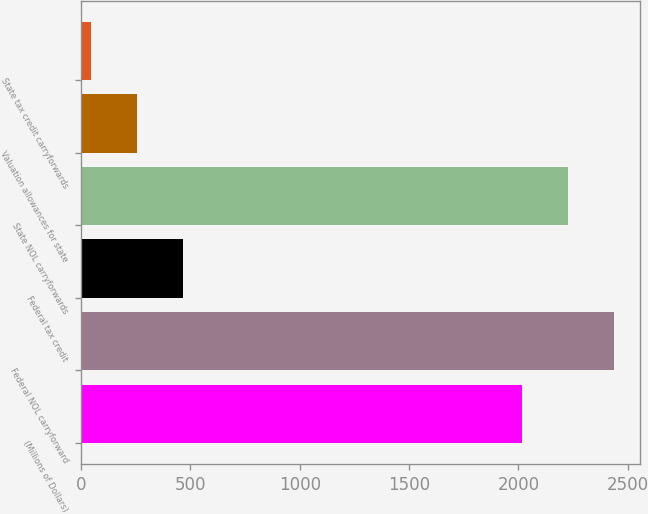<chart> <loc_0><loc_0><loc_500><loc_500><bar_chart><fcel>(Millions of Dollars)<fcel>Federal NOL carryforward<fcel>Federal tax credit<fcel>State NOL carryforwards<fcel>Valuation allowances for state<fcel>State tax credit carryforwards<nl><fcel>2015<fcel>2436.6<fcel>466.6<fcel>2225.8<fcel>255.8<fcel>45<nl></chart> 